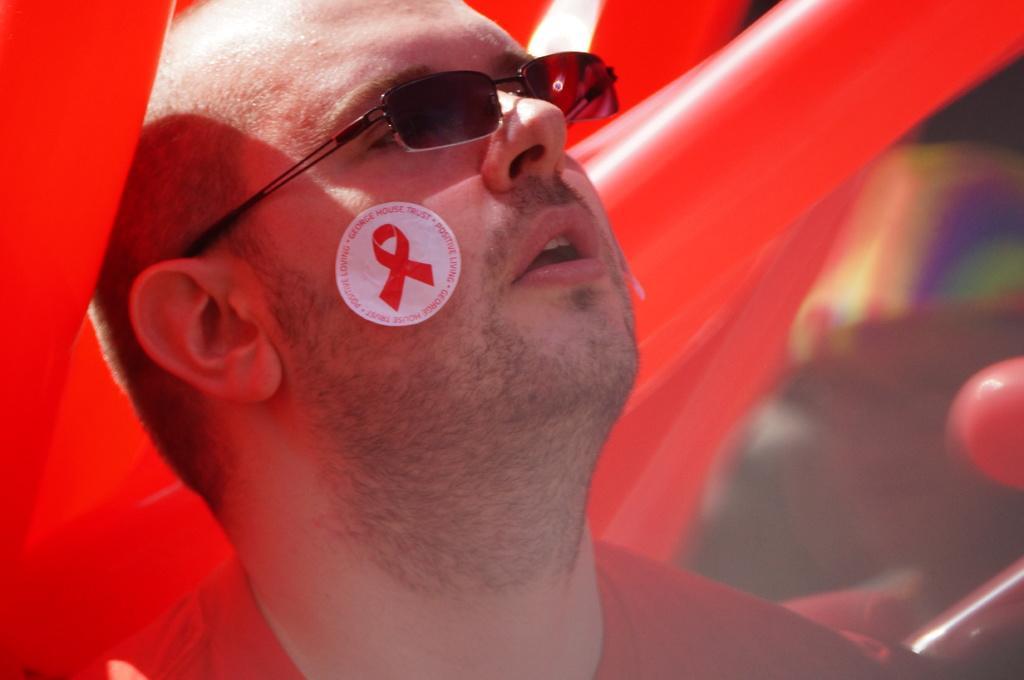How would you summarize this image in a sentence or two? In this image I can see the person with red color dress and the goggles. In the background I can see the red color balloons and the blurred background. 